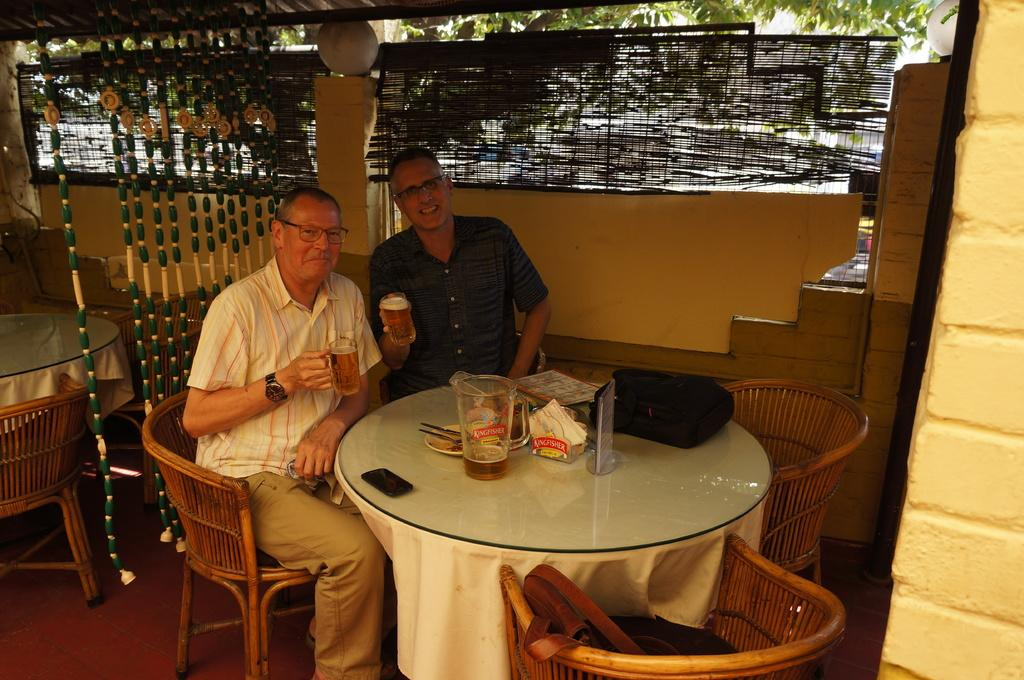How many people are seated in the image? There are 2 people seated on wooden chairs. What are the people holding in their hands? The people are holding a glass. What objects can be seen on the table? There is a jug, a phone, and a bag on the table. What is visible behind the people? There is a wall behind the people. What can be seen outside through the windows or openings? There are trees visible outside. How many rabbits are hopping around on the table in the image? There are no rabbits present in the image; the table only contains a jug, a phone, and a bag. What is the wind doing in the image? There is no mention of wind in the image, as it focuses on the people, their glasses, and the objects on the table. 